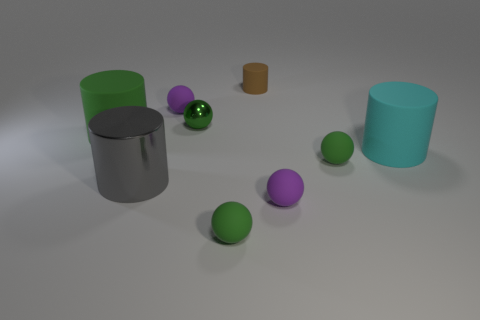What number of objects are big objects on the right side of the brown rubber thing or green rubber things? On the right side of the brown cylindrical object, there appear to be two large green cylinders. Alongside the green objects, if we consider the purple and green spheres as 'big' based on their size relative to the surrounding items, the answer would be four. The exact classification of 'big' might require further context regarding the size comparison criteria. 